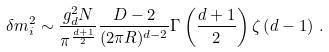Convert formula to latex. <formula><loc_0><loc_0><loc_500><loc_500>\delta m ^ { 2 } _ { i } \sim \frac { g _ { d } ^ { 2 } N } { \pi ^ { \frac { d + 1 } { 2 } } } \frac { D - 2 } { ( 2 \pi R ) ^ { d - 2 } } \Gamma \left ( \frac { d + 1 } { 2 } \right ) \zeta \left ( d - 1 \right ) \, .</formula> 